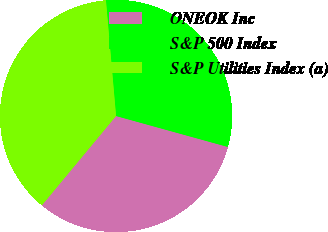Convert chart. <chart><loc_0><loc_0><loc_500><loc_500><pie_chart><fcel>ONEOK Inc<fcel>S&P 500 Index<fcel>S&P Utilities Index (a)<nl><fcel>31.73%<fcel>30.69%<fcel>37.58%<nl></chart> 